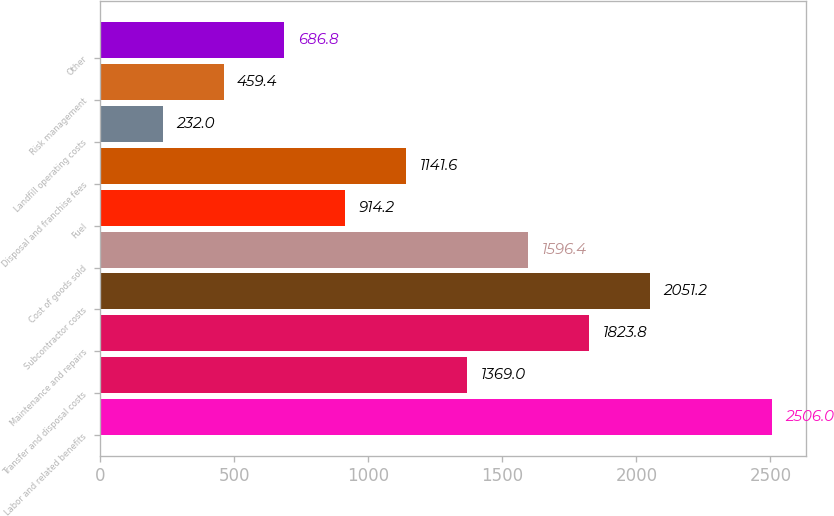<chart> <loc_0><loc_0><loc_500><loc_500><bar_chart><fcel>Labor and related benefits<fcel>Transfer and disposal costs<fcel>Maintenance and repairs<fcel>Subcontractor costs<fcel>Cost of goods sold<fcel>Fuel<fcel>Disposal and franchise fees<fcel>Landfill operating costs<fcel>Risk management<fcel>Other<nl><fcel>2506<fcel>1369<fcel>1823.8<fcel>2051.2<fcel>1596.4<fcel>914.2<fcel>1141.6<fcel>232<fcel>459.4<fcel>686.8<nl></chart> 